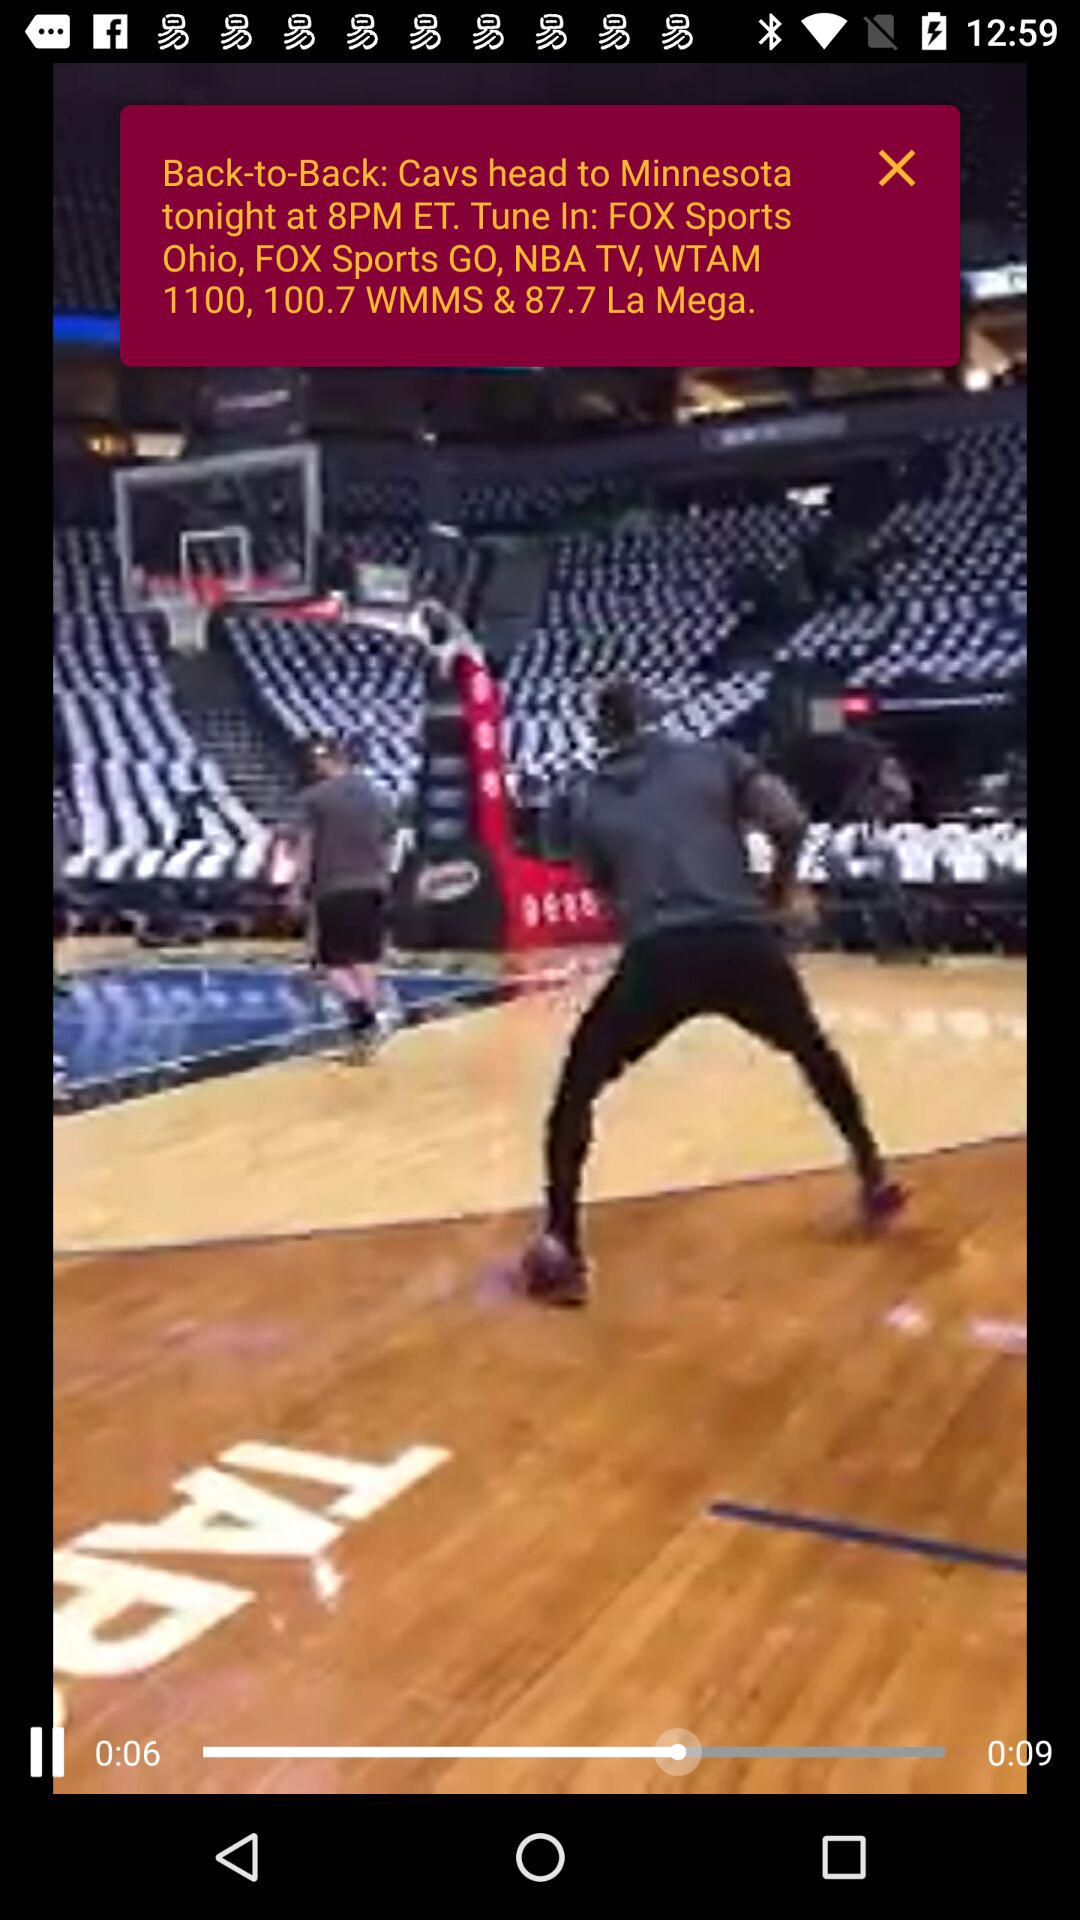How many more seconds are left than have passed?
Answer the question using a single word or phrase. 3 